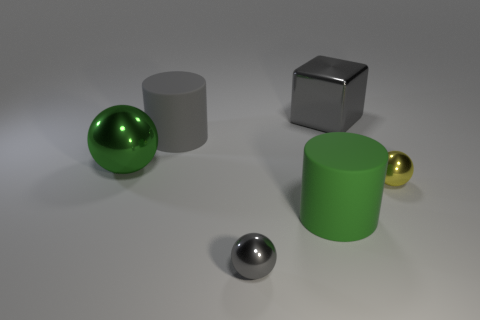Subtract all yellow spheres. How many spheres are left? 2 Add 1 small brown cubes. How many objects exist? 7 Subtract 1 spheres. How many spheres are left? 2 Subtract all cubes. How many objects are left? 5 Subtract 1 green balls. How many objects are left? 5 Subtract all green cylinders. Subtract all green balls. How many cylinders are left? 1 Subtract all green matte objects. Subtract all big objects. How many objects are left? 1 Add 6 big gray shiny blocks. How many big gray shiny blocks are left? 7 Add 4 big gray rubber spheres. How many big gray rubber spheres exist? 4 